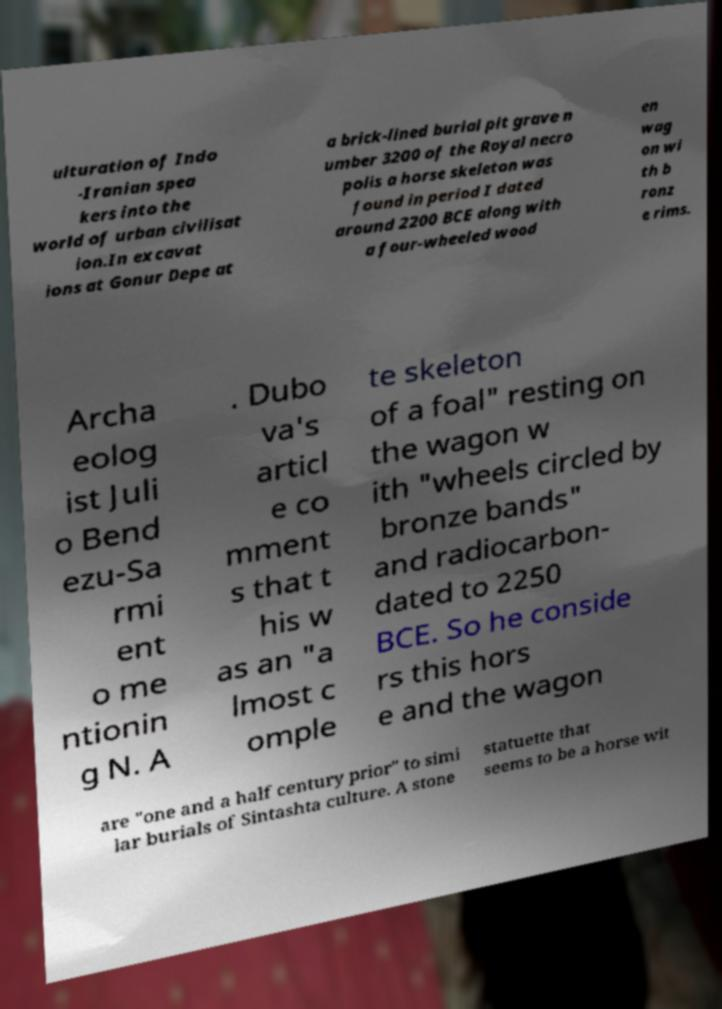Could you assist in decoding the text presented in this image and type it out clearly? ulturation of Indo -Iranian spea kers into the world of urban civilisat ion.In excavat ions at Gonur Depe at a brick-lined burial pit grave n umber 3200 of the Royal necro polis a horse skeleton was found in period I dated around 2200 BCE along with a four-wheeled wood en wag on wi th b ronz e rims. Archa eolog ist Juli o Bend ezu-Sa rmi ent o me ntionin g N. A . Dubo va's articl e co mment s that t his w as an "a lmost c omple te skeleton of a foal" resting on the wagon w ith "wheels circled by bronze bands" and radiocarbon- dated to 2250 BCE. So he conside rs this hors e and the wagon are "one and a half century prior" to simi lar burials of Sintashta culture. A stone statuette that seems to be a horse wit 